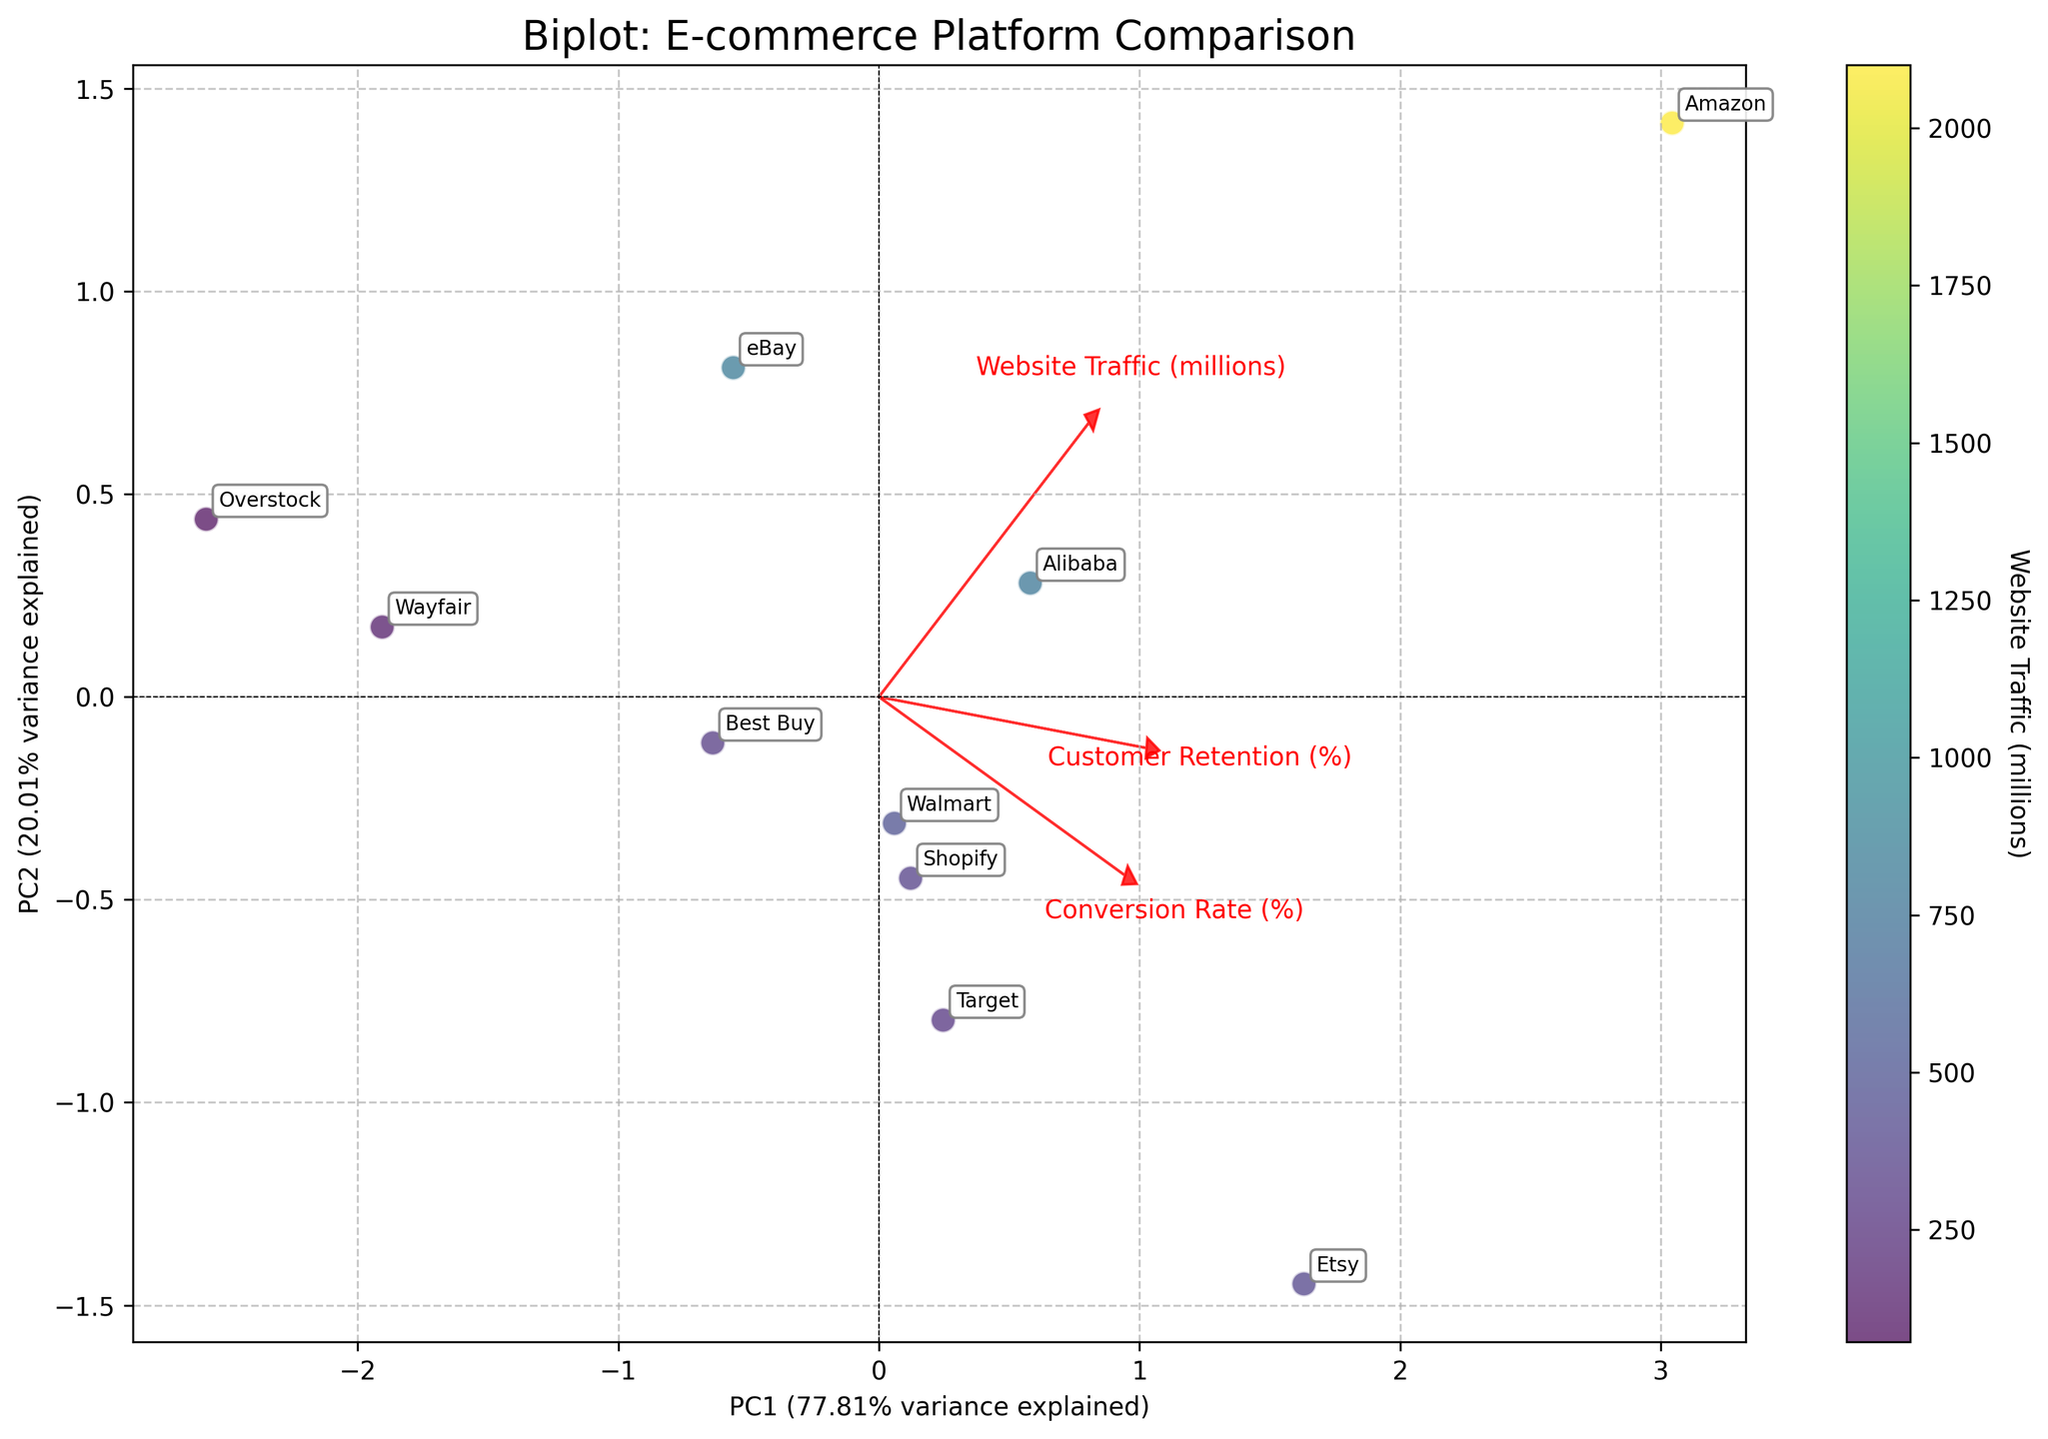How many e-commerce platforms are compared in the biplot? The number of data points (scatter points) on the biplot corresponds to the number of e-commerce platforms being analyzed. By counting these points, we determine that there are 10 platforms.
Answer: 10 Which e-commerce platform has the highest website traffic? We see the color gradient from light to dark representing website traffic. The lightest point corresponds to the highest website traffic, which is Amazon.
Answer: Amazon Which principal component (PC) explains more variance in the data? On the X-axis, we see the variance explained is a percentage. The axis label for PC1 shows a higher percentage than PC2, so PC1 explains more variance.
Answer: PC1 What relationship can be inferred between customer retention and website traffic? The vector arrows in the biplot for "Customer Retention (%)" and "Website Traffic (millions)" show their correlation. Since the arrows point in roughly the same direction, we infer these variables are positively correlated.
Answer: Positively correlated Rank the platforms by conversion rate. On the biplot, the "Conversion Rate (%)" vector direction helps to visualize which platforms are farthest along this vector. By relative positions, Etsy has the highest, followed by Amazon, Walmart, Target, Shopify, Best Buy, Alibaba, eBay, Wayfair, and Overstock.
Answer: Etsy > Amazon > Walmart > Target > Shopify > Best Buy > Alibaba > eBay > Wayfair > Overstock Which e-commerce platform shows a balance between a high conversion rate and high customer retention? Platforms closer to the arrow directions for both "Conversion Rate (%)" and "Customer Retention (%)" are balanced. Etsy, sitting close to both these arrows, exemplifies balance.
Answer: Etsy Are there any platforms that cluster together, and what do they have in common? By looking at the biplot, platforms that are close to each other form clusters. Shopify, Target, and Best Buy cluster together, suggesting similar metrics in website traffic, conversion rates, and customer retention rates.
Answer: Shopify, Target, Best Buy Which e-commerce platform appears to have the lowest customer retention rate? By observing the position along the "Customer Retention (%)" vector, Overstock is the furthest opposite to the arrow, indicating the lowest retention.
Answer: Overstock 